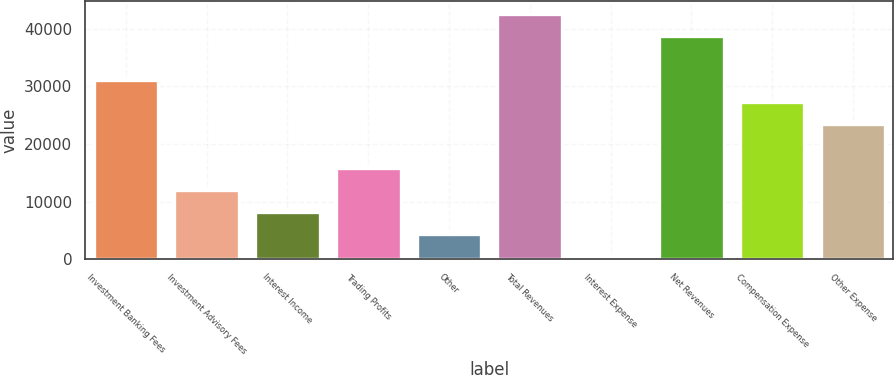Convert chart to OTSL. <chart><loc_0><loc_0><loc_500><loc_500><bar_chart><fcel>Investment Banking Fees<fcel>Investment Advisory Fees<fcel>Interest Income<fcel>Trading Profits<fcel>Other<fcel>Total Revenues<fcel>Interest Expense<fcel>Net Revenues<fcel>Compensation Expense<fcel>Other Expense<nl><fcel>31113.8<fcel>11978.3<fcel>8151.2<fcel>15805.4<fcel>4324.1<fcel>42595.1<fcel>497<fcel>38768<fcel>27286.7<fcel>23459.6<nl></chart> 